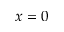Convert formula to latex. <formula><loc_0><loc_0><loc_500><loc_500>x = 0</formula> 